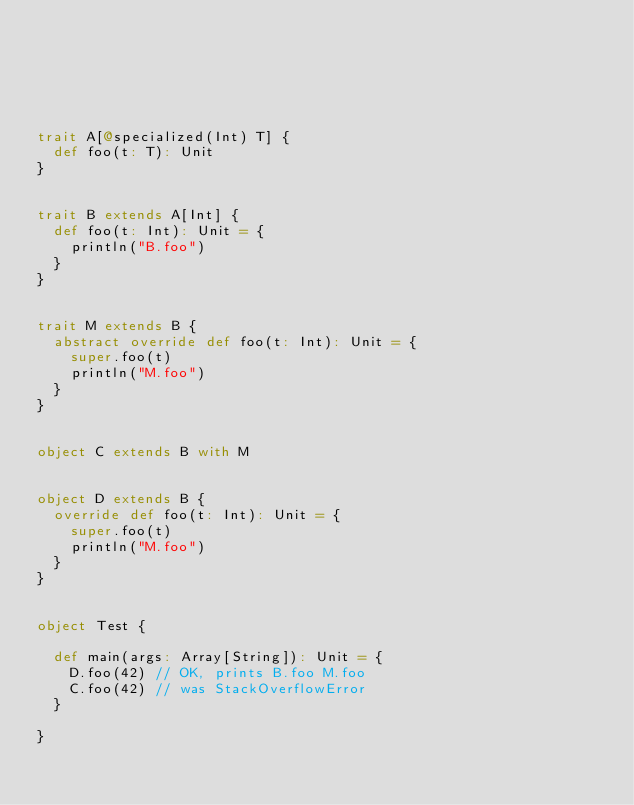Convert code to text. <code><loc_0><loc_0><loc_500><loc_500><_Scala_>





trait A[@specialized(Int) T] {
  def foo(t: T): Unit
}


trait B extends A[Int] {
  def foo(t: Int): Unit = {
    println("B.foo")
  }
}


trait M extends B {
  abstract override def foo(t: Int): Unit = {
    super.foo(t)
    println("M.foo")
  }
}


object C extends B with M


object D extends B {
  override def foo(t: Int): Unit = {
    super.foo(t)
    println("M.foo")
  }
}


object Test {

  def main(args: Array[String]): Unit = {
    D.foo(42) // OK, prints B.foo M.foo
    C.foo(42) // was StackOverflowError
  }

}


</code> 